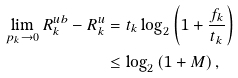<formula> <loc_0><loc_0><loc_500><loc_500>\lim _ { p _ { k } \to 0 } R ^ { u b } _ { k } - R ^ { u } _ { k } & = t _ { k } \log _ { 2 } \left ( 1 + \frac { f _ { k } } { t _ { k } } \right ) \\ & \leq \log _ { 2 } \left ( 1 + M \right ) ,</formula> 